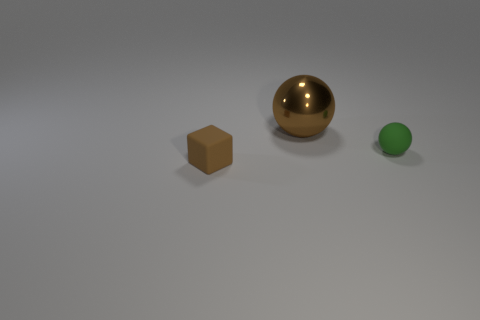Add 1 metal spheres. How many objects exist? 4 Subtract all balls. How many objects are left? 1 Subtract 2 spheres. How many spheres are left? 0 Subtract all yellow spheres. Subtract all red cylinders. How many spheres are left? 2 Subtract all brown cylinders. How many brown balls are left? 1 Subtract all tiny brown rubber cylinders. Subtract all large objects. How many objects are left? 2 Add 3 big brown metallic balls. How many big brown metallic balls are left? 4 Add 1 tiny blue metallic blocks. How many tiny blue metallic blocks exist? 1 Subtract 0 brown cylinders. How many objects are left? 3 